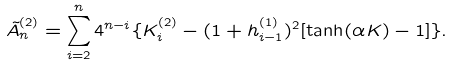Convert formula to latex. <formula><loc_0><loc_0><loc_500><loc_500>\tilde { A } _ { n } ^ { ( 2 ) } = \sum _ { i = 2 } ^ { n } 4 ^ { n - i } \{ K _ { i } ^ { ( 2 ) } - ( 1 + h _ { i - 1 } ^ { ( 1 ) } ) ^ { 2 } [ \tanh ( \alpha K ) - 1 ] \} .</formula> 